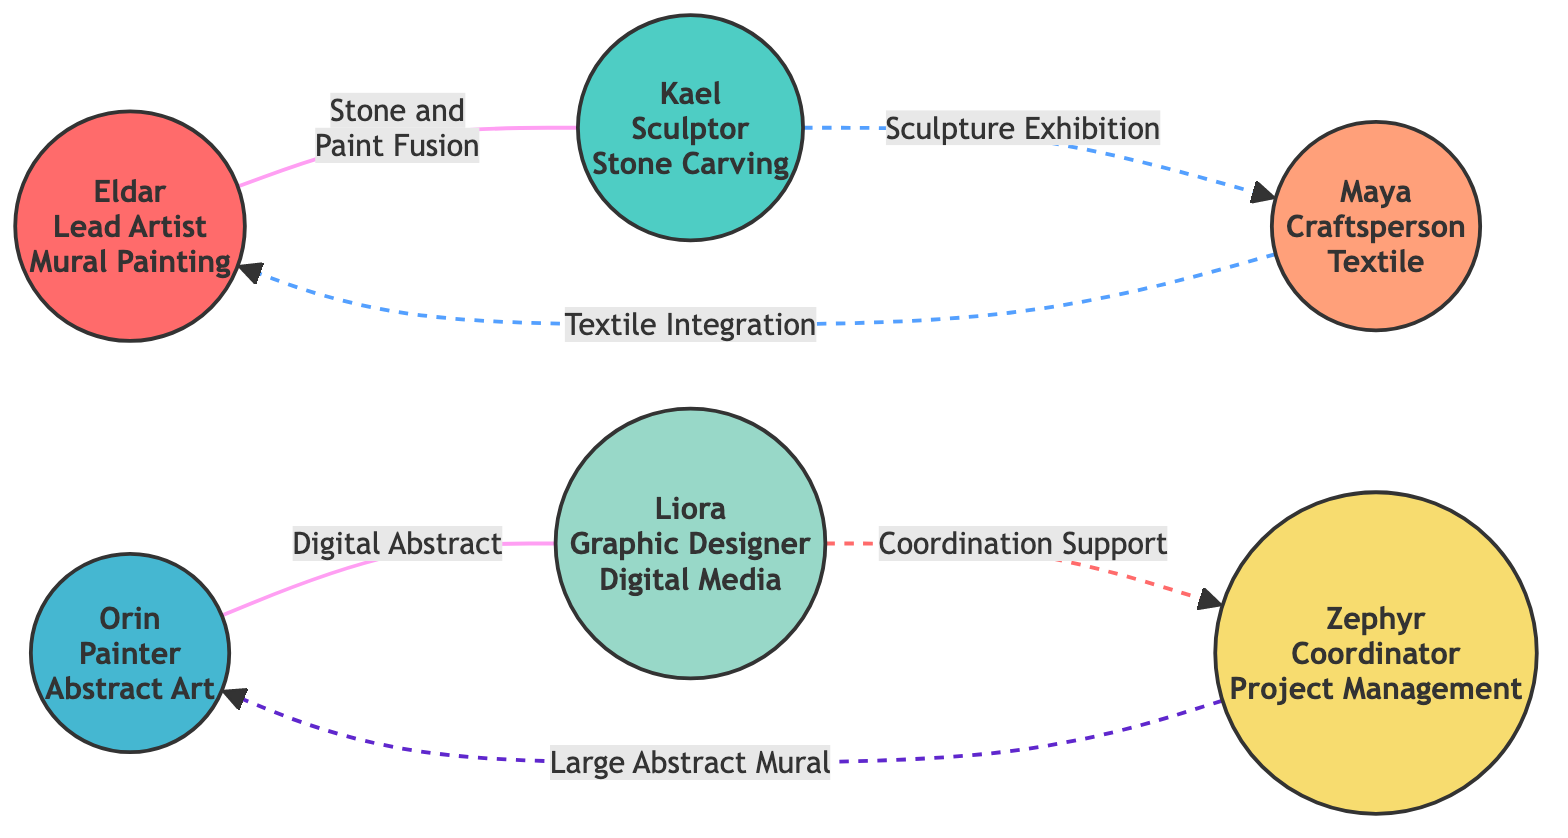What is the role of Eldar in the network? The diagram indicates that Eldar is identified as the "Lead Artist." This information is present in the node representing Eldar, which provides specific details about each participant's role.
Answer: Lead Artist How many artists are involved in the collaboration network? By counting the nodes in the diagram, there are six distinct individuals listed: Eldar, Kael, Orin, Maya, Liora, and Zephyr. Each of these represents an artist or role in the collaboration.
Answer: Six Which project involves both Eldar and Kael? The diagram shows a direct link labeled "Stone and Paint Fusion" connecting Eldar and Kael, indicating that they are collaborating on this specific project. The information is directly stated on the connection between their nodes.
Answer: Stone and Paint Fusion What type of relationship exists between Orin and Liora? The diagram classifies the relationship between Orin and Liora as a "Collaboration." This classification is evident from the link that directly connects the two nodes along with the associated project name.
Answer: Collaboration Who provides advisory support to Zephyr? The connection in the diagram shows that Liora provides "Advisory" support to Zephyr. This is shown through the dashed link between Liora and Zephyr, clarifying the type of support they have for one another in their roles.
Answer: Liora Which artist provides support to Eldar in the project "Textile Integration"? The diagram illustrates that Maya offers "Support" to Eldar on the project "Textile Integration." This is visible from the dashed link between their nodes, specifying the nature of their interaction.
Answer: Maya How many different types of relationships are shown in the network? By examining the various links in the diagram, there are three distinct types of relationships: Collaboration, Support, and Advisory. These are categorized by the labels and dashed lines connecting the artists.
Answer: Three Which node receives management from Zephyr? The diagram indicates that Zephyr manages Orin in the project called "Large Abstract Mural." The association is marked with a solid line indicating the management relationship present in the diagram.
Answer: Orin 